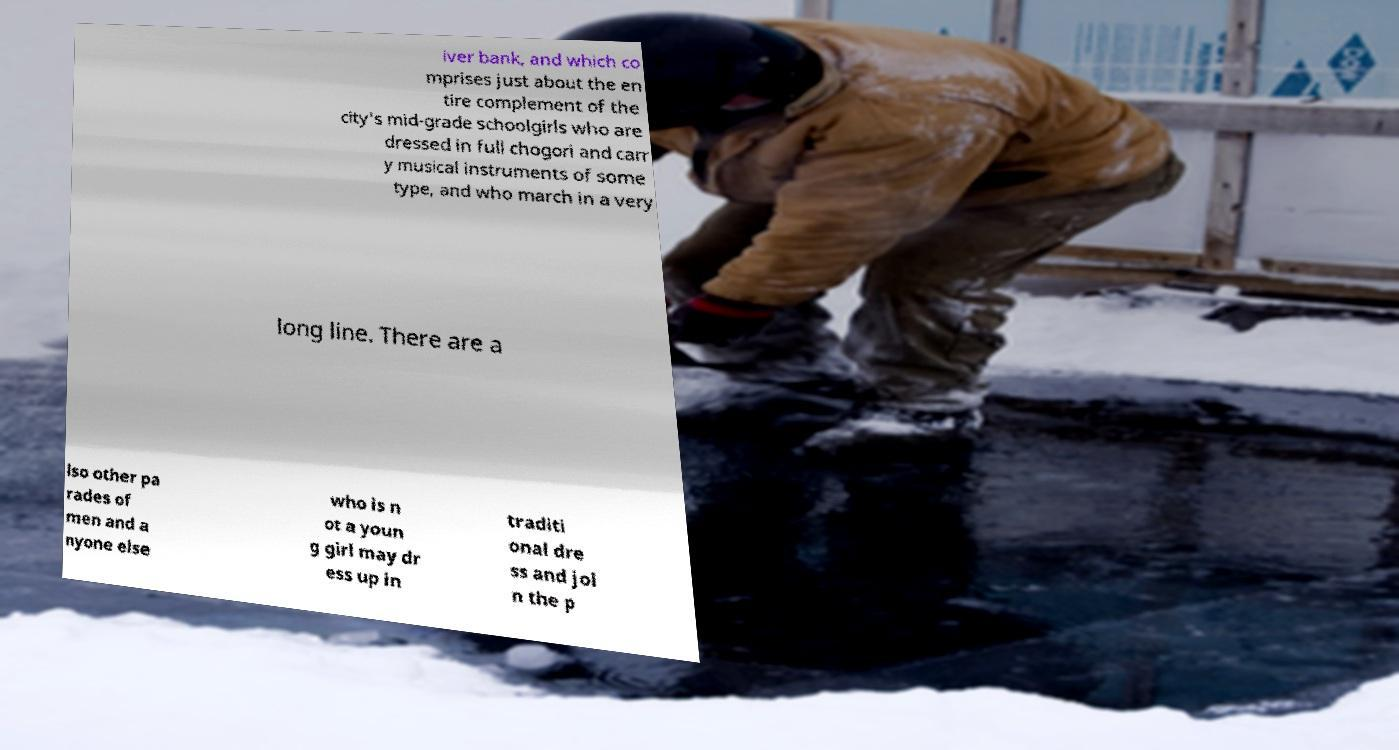I need the written content from this picture converted into text. Can you do that? iver bank, and which co mprises just about the en tire complement of the city's mid-grade schoolgirls who are dressed in full chogori and carr y musical instruments of some type, and who march in a very long line. There are a lso other pa rades of men and a nyone else who is n ot a youn g girl may dr ess up in traditi onal dre ss and joi n the p 